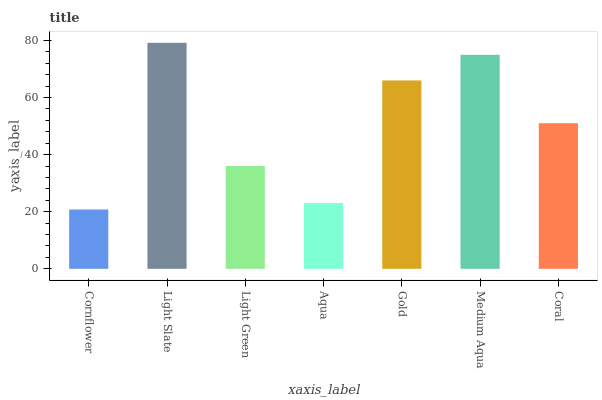Is Cornflower the minimum?
Answer yes or no. Yes. Is Light Slate the maximum?
Answer yes or no. Yes. Is Light Green the minimum?
Answer yes or no. No. Is Light Green the maximum?
Answer yes or no. No. Is Light Slate greater than Light Green?
Answer yes or no. Yes. Is Light Green less than Light Slate?
Answer yes or no. Yes. Is Light Green greater than Light Slate?
Answer yes or no. No. Is Light Slate less than Light Green?
Answer yes or no. No. Is Coral the high median?
Answer yes or no. Yes. Is Coral the low median?
Answer yes or no. Yes. Is Light Green the high median?
Answer yes or no. No. Is Gold the low median?
Answer yes or no. No. 